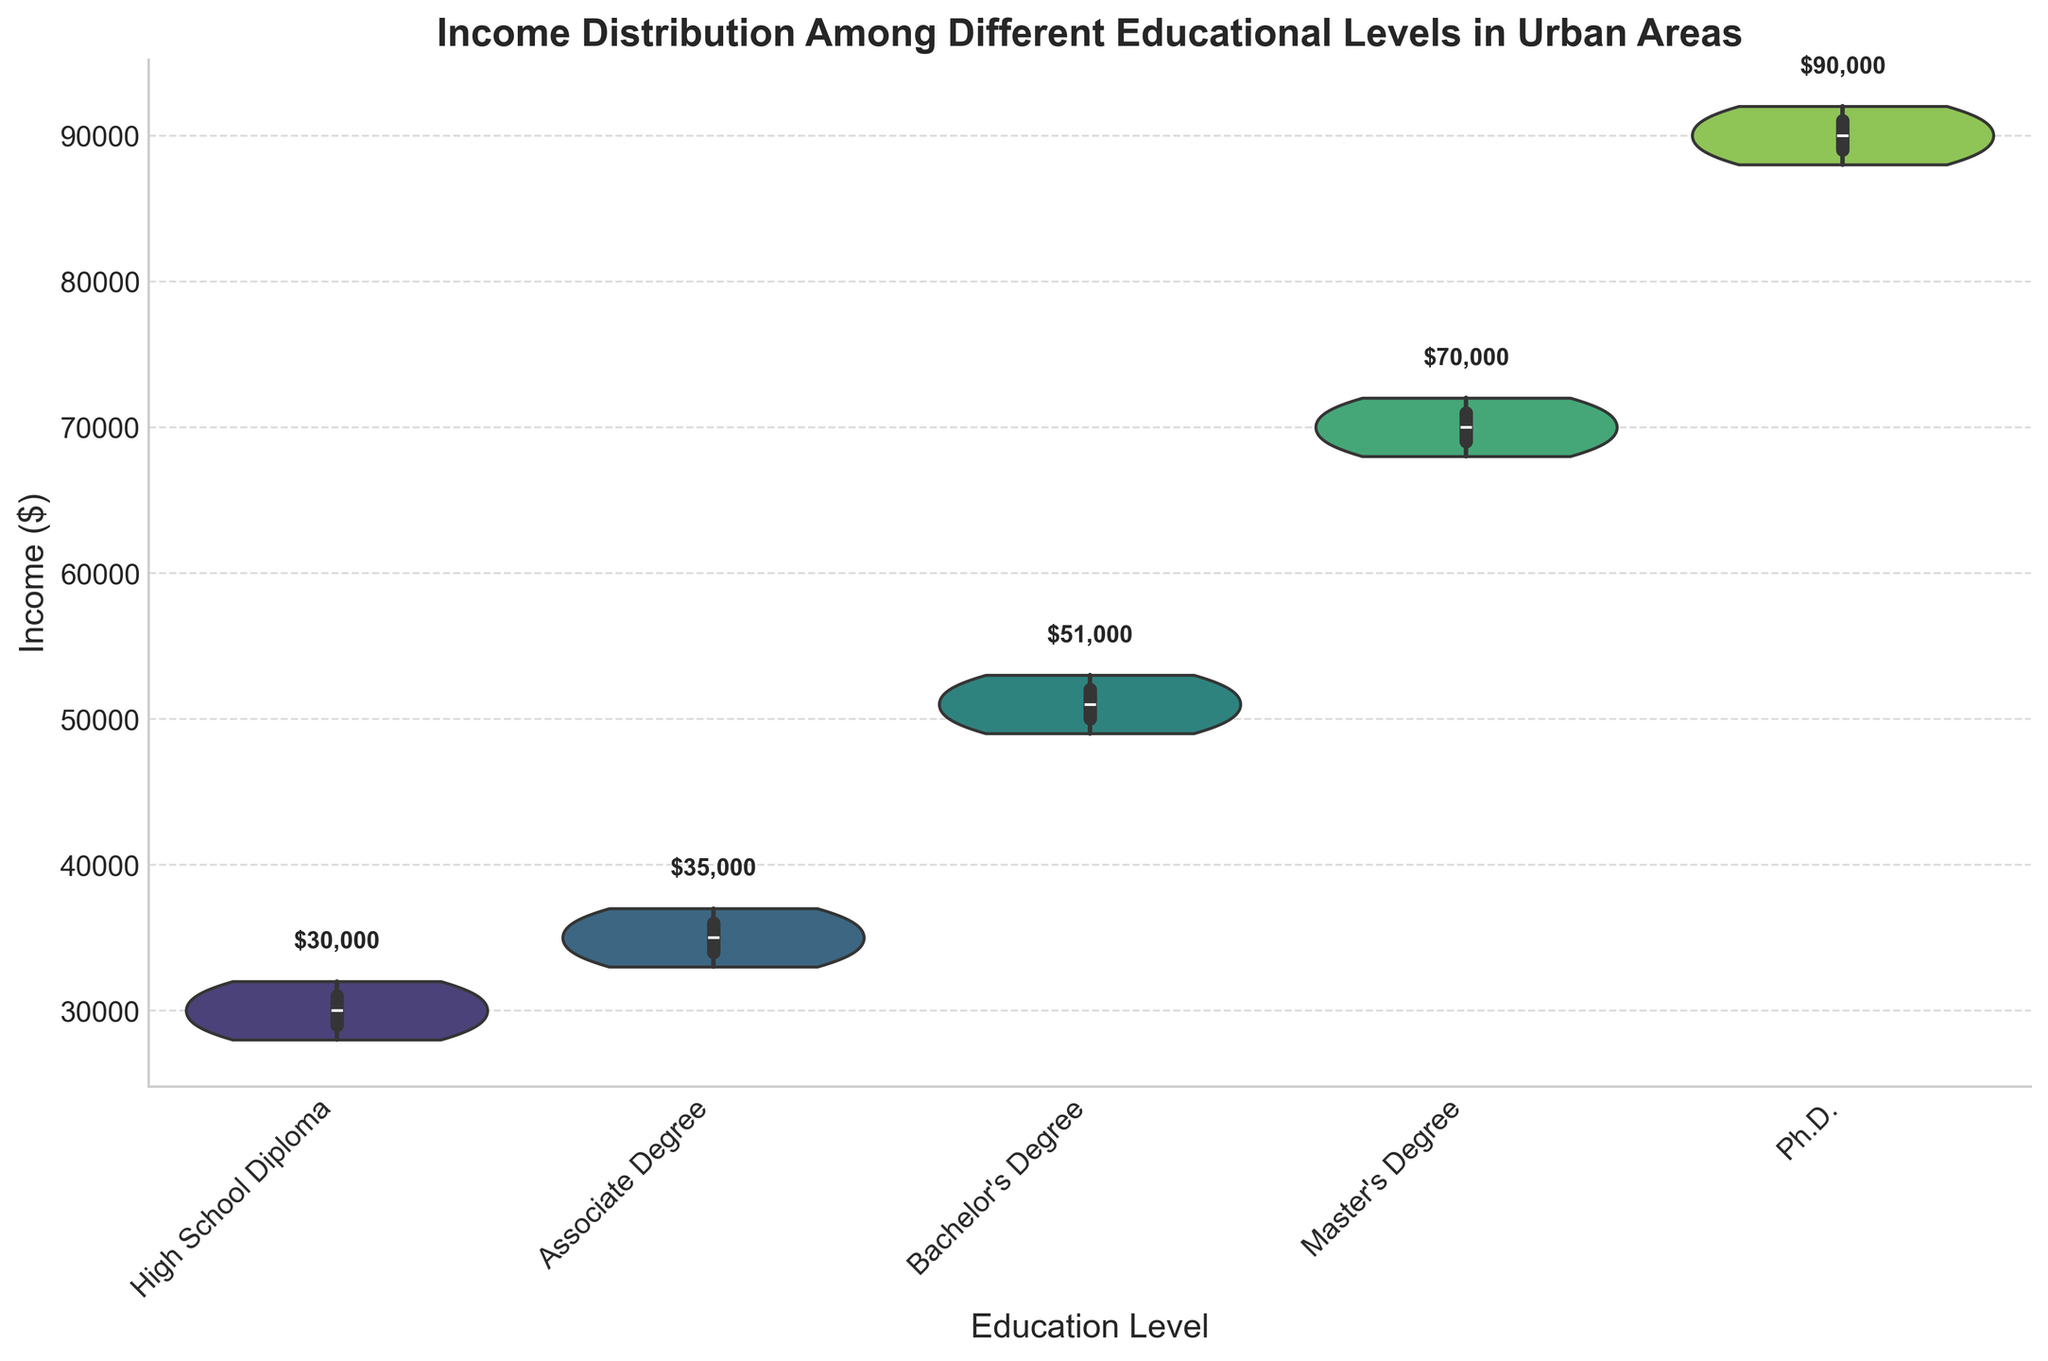What is the average income for individuals with a Bachelor's Degree? To find the average income for individuals with a Bachelor's Degree, add up all the incomes in this group ($50,000 + $52,000 + $51,000 + $53,000 + $49,000 = $255,000) and divide by the number of individuals (5). The average income is $255,000 / 5 = $51,000.
Answer: $51,000 Which educational level has the highest median income? The violin chart shows box plots within each violin representing the quartiles of income. The median is represented by the middle line in the box plot. Observing the chart, the Ph.D. group has the highest middle line representing its median income.
Answer: Ph.D What is the income range for individuals with a Master’s Degree? The income range can be determined from the extremes of the violin plot. For the Master's Degree group, the lowest income is $68,000 and the highest income is $72,000, so the range is $72,000 - $68,000 = $4,000.
Answer: $4,000 Compare the income distributions of individuals with a High School Diploma and those with an Associate Degree. Which group has a wider range of incomes? Observing the width of the violin plots, the High School Diploma group spans incomes from $28,000 to $32,000, which gives a range of $4,000. The Associate Degree spans from $33,000 to $37,000, also giving a range of $4,000. Both groups have the same income range.
Answer: Both have the same range Which group shows more variability in income: those with Associate Degrees or Bachelor’s Degrees? Variability can be observed as the spread of the violin plot. The Bachelor's Degree group shows a larger spread compared to the Associate Degree group. This is visible through the wider vertical span of the Bachelor’s Degree violin plot.
Answer: Bachelor's Degrees How does the income distribution of individuals with a Ph.D. compare to those with a High School Diploma? The income distribution for Ph.D. holders is significantly higher and less variable compared to those with a High School Diploma, which has a lower center and slightly more variability. This is evident from the vertical placement and compressed yet wider nature of the Ph.D. violin plot.
Answer: Ph.D. holders have higher and less variable incomes What is the mean income annotation for individuals with an Associate Degree? The mean income for each educational level is annotated above the violin plots. Observing the plot, the Associate Degree group has its mean income annotated as $35,200.
Answer: $35,200 Which educational level has the most tightly grouped income distribution? The tightness of income distribution can be seen from the density and compactness of the violin plot. The High School Diploma group shows a very compact and narrow plot, indicating tightly grouped income distributions.
Answer: High School Diploma What are the incomes at the 25th and 75th percentiles for the Master's Degree group? The 25th and 75th percentiles are represented by the bottom and top edges of the box in the box plot inside the violin. Observing the Master's Degree group, the 25th percentile is around $68,000, and the 75th percentile is around $72,000.
Answer: $68,000 and $72,000 